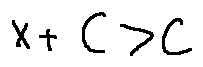<formula> <loc_0><loc_0><loc_500><loc_500>x + C > C</formula> 